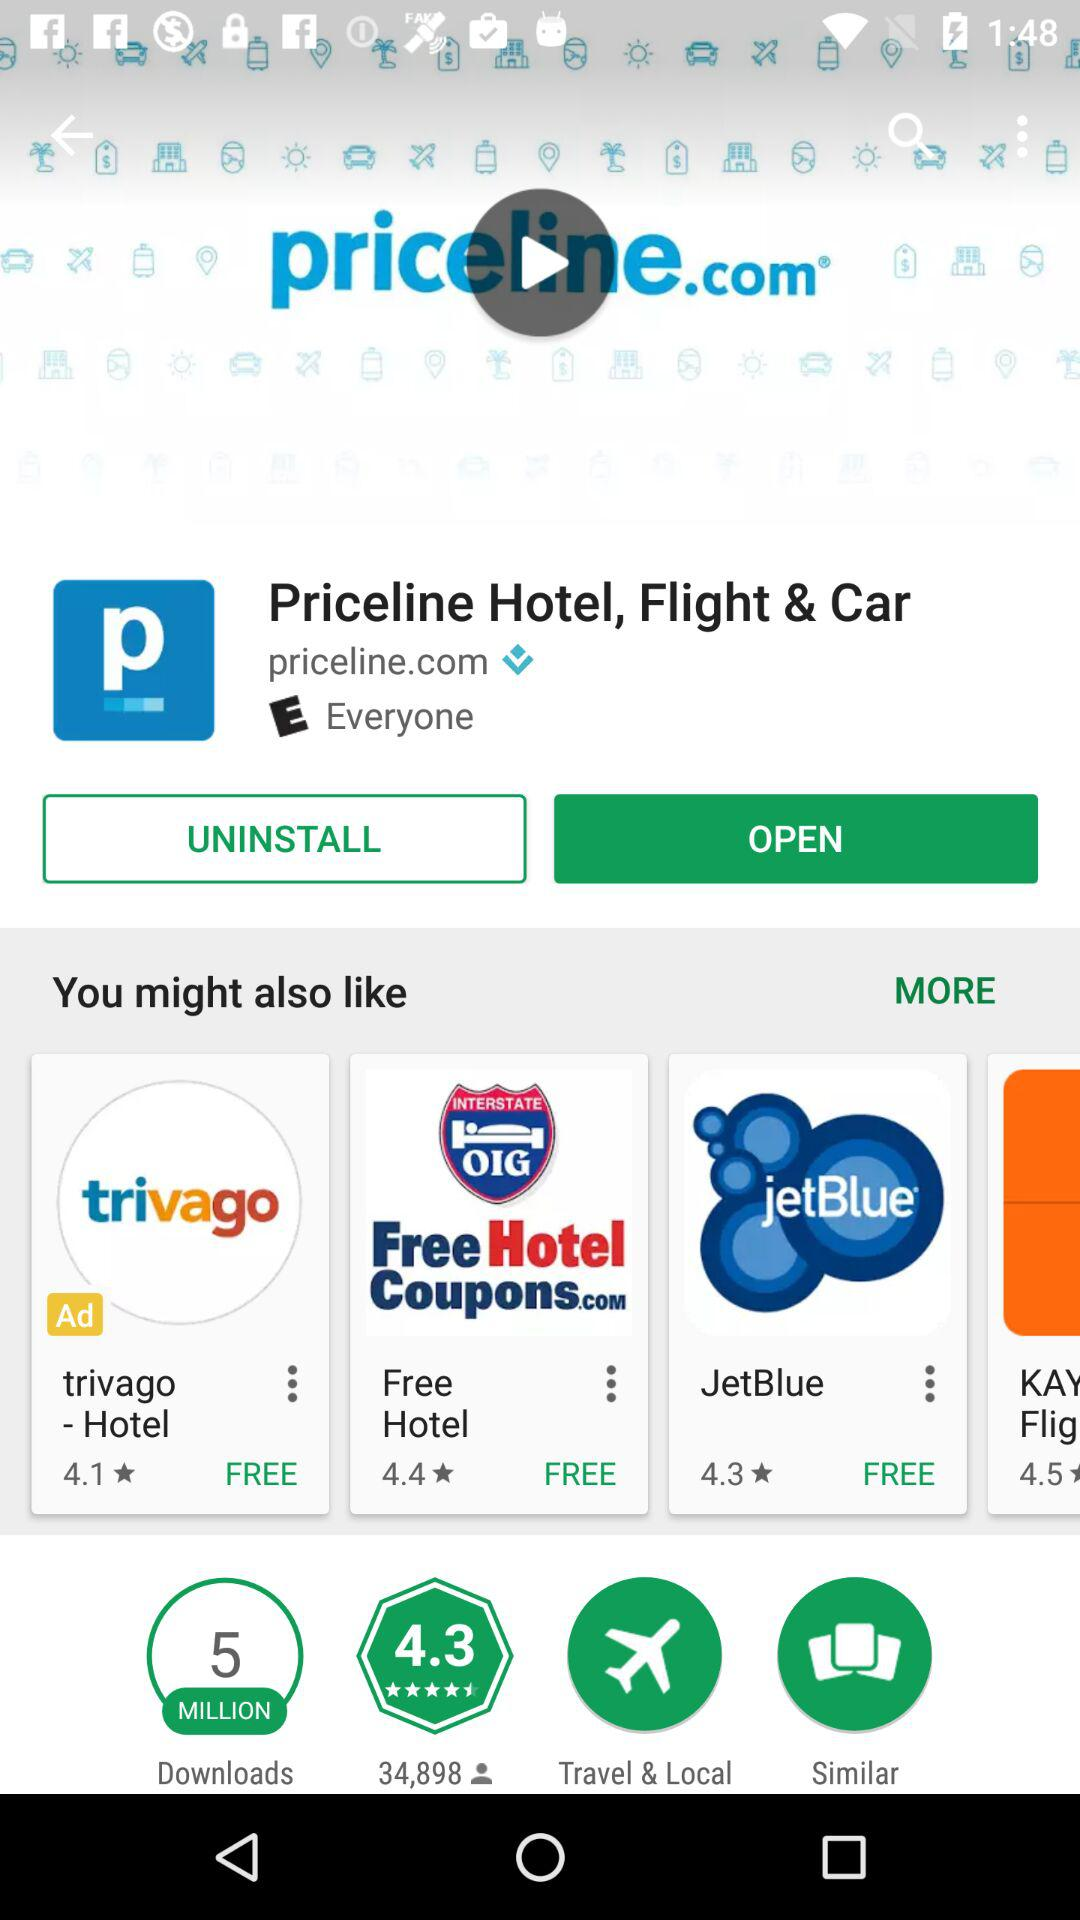What is the rating of the application named Trivago? The rating is 4.1 stars. 